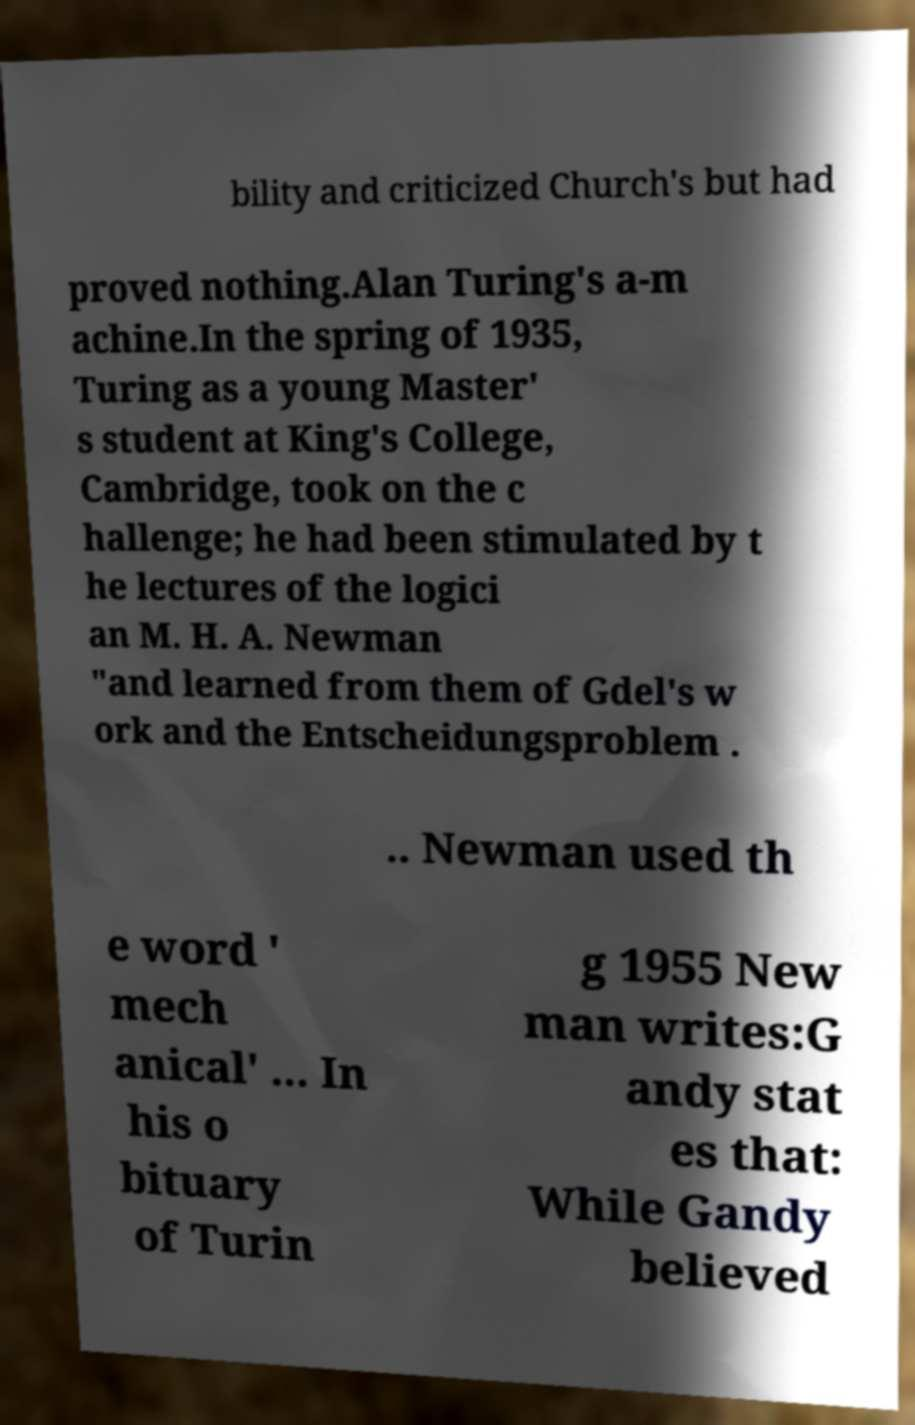Can you accurately transcribe the text from the provided image for me? bility and criticized Church's but had proved nothing.Alan Turing's a-m achine.In the spring of 1935, Turing as a young Master' s student at King's College, Cambridge, took on the c hallenge; he had been stimulated by t he lectures of the logici an M. H. A. Newman "and learned from them of Gdel's w ork and the Entscheidungsproblem . .. Newman used th e word ' mech anical' ... In his o bituary of Turin g 1955 New man writes:G andy stat es that: While Gandy believed 